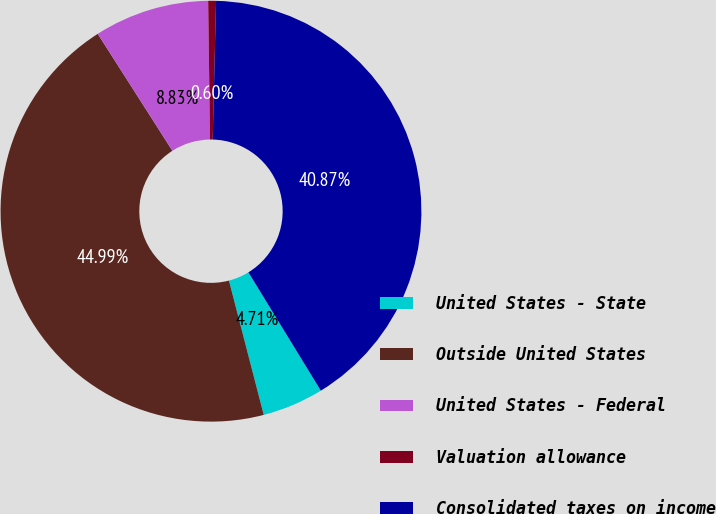Convert chart to OTSL. <chart><loc_0><loc_0><loc_500><loc_500><pie_chart><fcel>United States - State<fcel>Outside United States<fcel>United States - Federal<fcel>Valuation allowance<fcel>Consolidated taxes on income<nl><fcel>4.71%<fcel>44.99%<fcel>8.83%<fcel>0.6%<fcel>40.87%<nl></chart> 